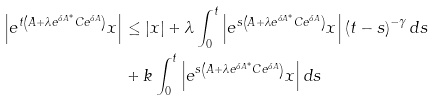Convert formula to latex. <formula><loc_0><loc_0><loc_500><loc_500>\left | e ^ { t \left ( A + \lambda e ^ { \delta A ^ { \ast } } C e ^ { \delta A } \right ) } x \right | & \leq \left | x \right | + \lambda \int _ { 0 } ^ { t } \left | e ^ { s \left ( A + \lambda e ^ { \delta A ^ { \ast } } C e ^ { \delta A } \right ) } x \right | \left ( t - s \right ) ^ { - \gamma } d s \\ & + k \int _ { 0 } ^ { t } \left | e ^ { s \left ( A + \lambda e ^ { \delta A ^ { \ast } } C e ^ { \delta A } \right ) } x \right | d s</formula> 